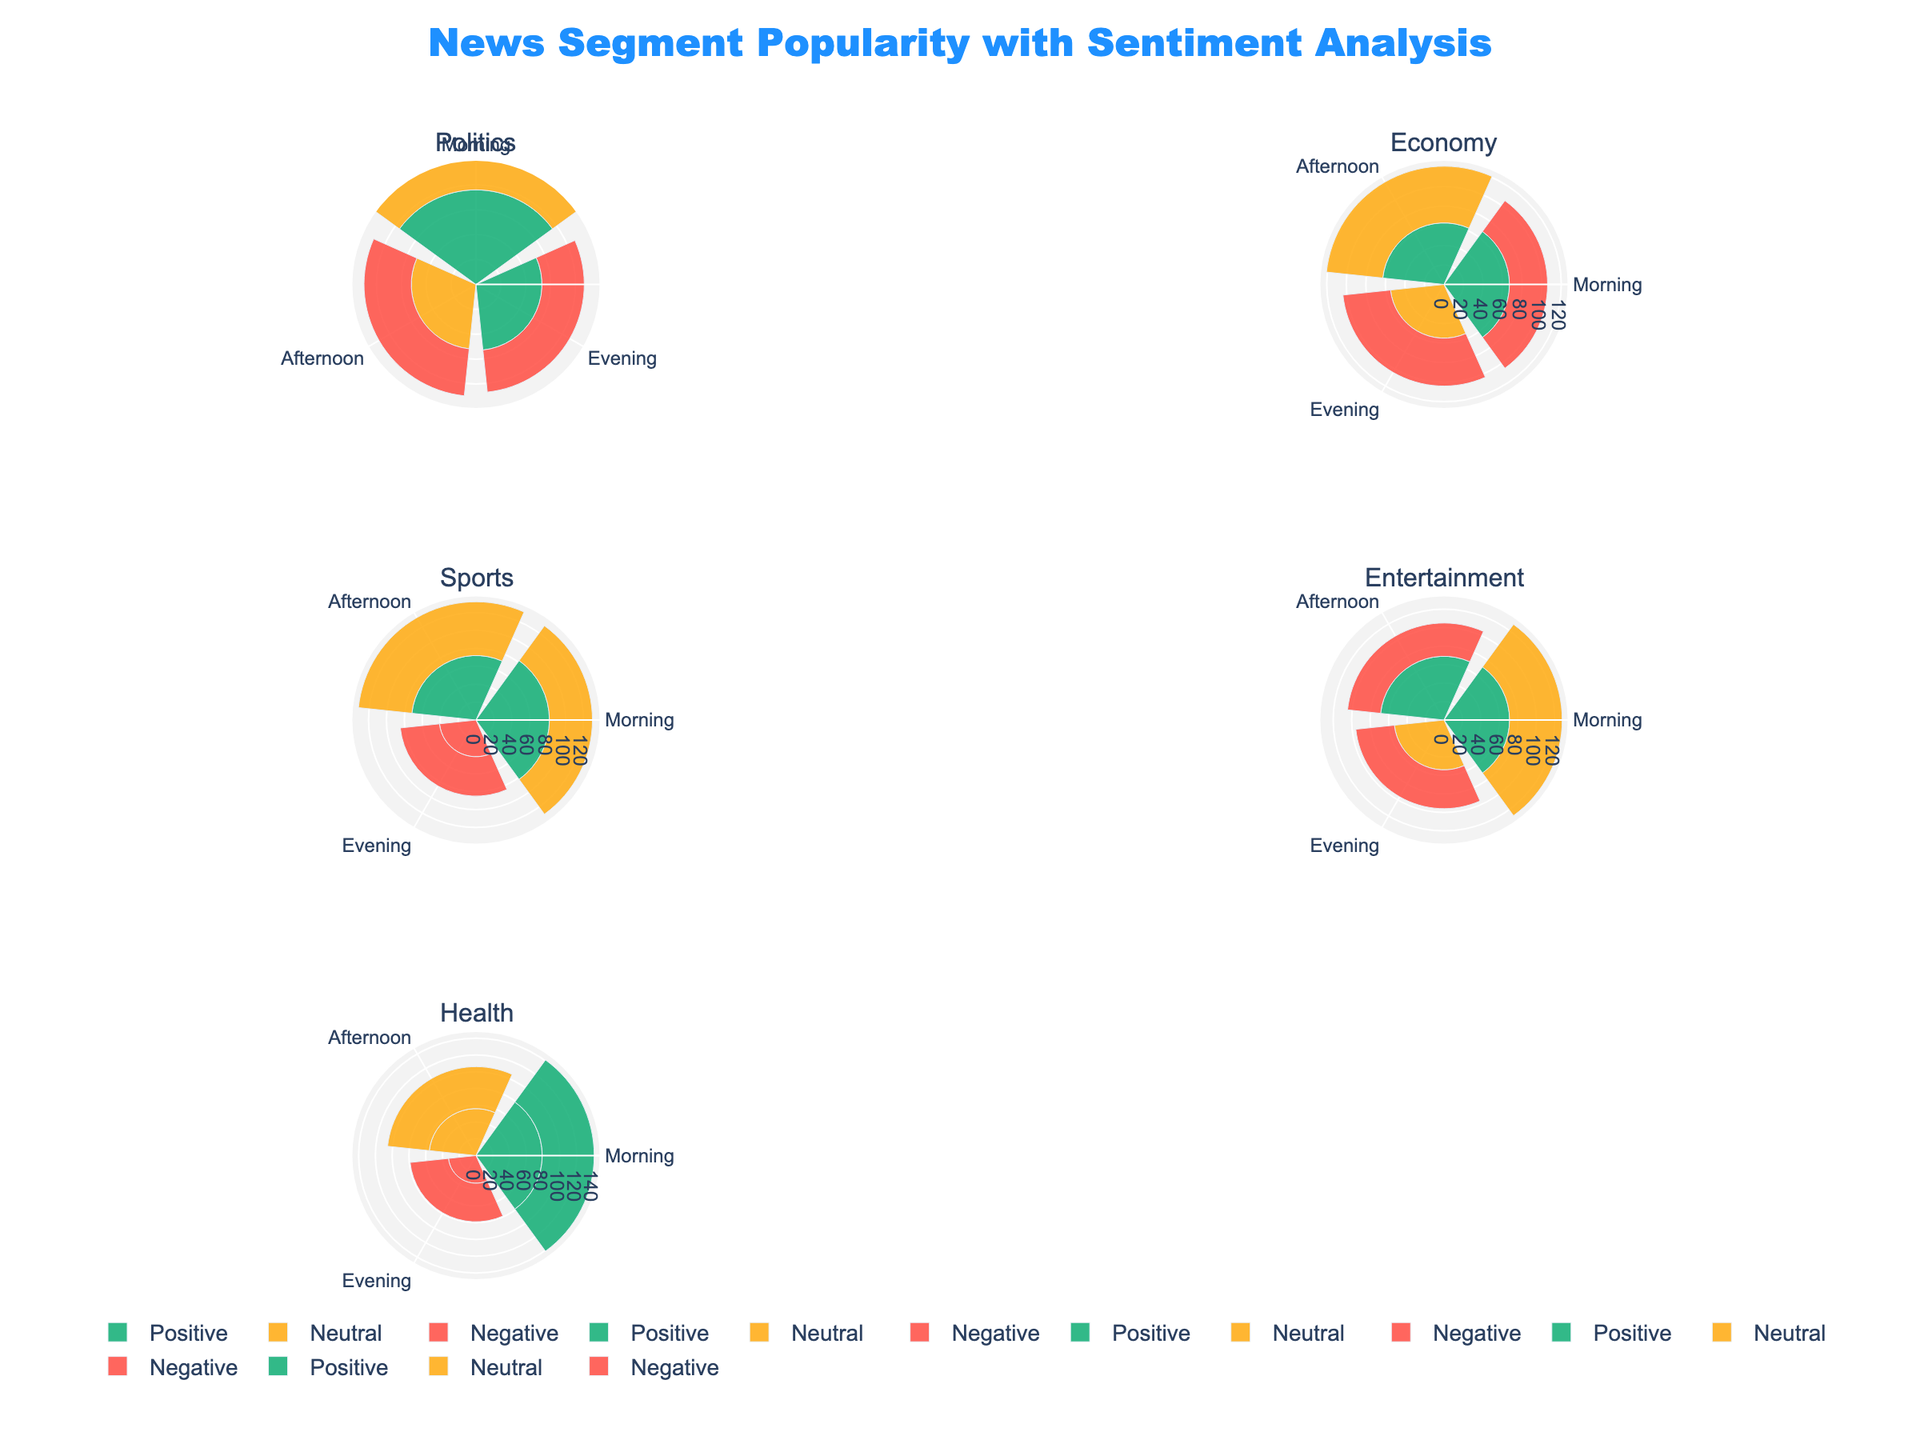What's the most popular news segment in the Health category? Look at the subplot for Health and identify the segment with the highest popularity value. The "Fitness Tips" segment in the Morning has a popularity of 79, which is the highest in the Health category.
Answer: Fitness Tips (Morning) Which category has the highest overall popularity for Positive sentiment? Compare the highest popularity values for Positive sentiment in each category. Politics has 76, Economy has 67, Sports has 82, Entertainment has 71, and Health has 79. Therefore, Sports has the highest popularity for Positive sentiment.
Answer: Sports In which time period is the "Market Analysis" segment most popular? Look at the Economy subplot and find the "Market Analysis" segment. Compare its popularity values across the Morning, Afternoon, and Evening. The Morning time period has the highest popularity at 67.
Answer: Morning How does the Evening popularity of "Olympic Review" in Sports compare to the Evening popularity of "Medical Breakthroughs" in Health? Find the values for "Olympic Review" and "Medical Breakthroughs" in the Evening time period. "Olympic Review" in Sports has 44, while "Medical Breakthroughs" in Health has 46. 46 is higher than 44, so "Medical Breakthroughs" is more popular in the Evening compared to "Olympic Review."
Answer: Medical Breakthroughs is more popular Which sentiment has the lowest overall popularity in the Entertainment category? Check the popularity values for Positive, Neutral, and Negative sentiments in the Entertainment subplot. Positive: 71 and 69; Neutral: 57 and 54; Negative: 36 and 42. Negative sentiment has the lowest overall popularity.
Answer: Negative What is the average popularity of "Presidential Debate" in the Politics category across all time periods? Add up the popularity values for "Presidential Debate" in Morning (76), Afternoon (52), and Evening (34), then divide by 3. (76 + 52 + 34) / 3 = 162 / 3 = 54.
Answer: 54 Which segment has higher morning popularity, "Job Reports" in Economy or "Fitness Tips" in Health? Look at the Morning popularity values for "Job Reports" (39) and "Fitness Tips" (79). 79 is higher than 39.
Answer: Fitness Tips How does the popularity of the "Senate Hearings" segment in the Evening compare to the "Movie Reviews" segment in the Afternoon? Compare the values: "Senate Hearings" in the Evening is 53, and "Movie Reviews" in the Afternoon is 69. 69 is greater than 53.
Answer: Movie Reviews has higher popularity What is the least popular news segment in the Politics category? Compare all the segments in the Politics category for the lowest popularity value. "Presidential Debate" in the Evening has the lowest value of 34.
Answer: Presidential Debate (Evening) 